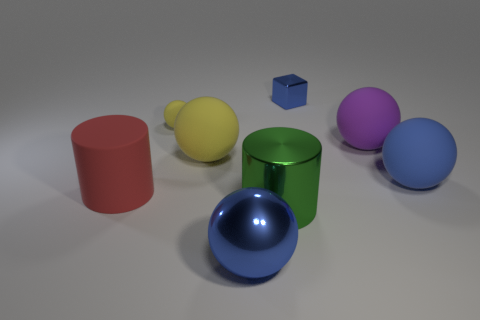There is a big green object that is the same shape as the red matte thing; what is it made of?
Provide a short and direct response. Metal. What is the shape of the large rubber thing right of the big purple matte thing?
Your response must be concise. Sphere. What number of other green objects are the same shape as the big green thing?
Offer a terse response. 0. Are there the same number of red things that are to the right of the large red rubber cylinder and blue spheres behind the shiny cube?
Offer a terse response. Yes. Are there any small cyan balls that have the same material as the large red object?
Offer a terse response. No. Is the large purple object made of the same material as the small ball?
Offer a very short reply. Yes. What number of blue things are tiny metal blocks or metallic things?
Ensure brevity in your answer.  2. Is the number of big blue matte balls behind the tiny shiny cube greater than the number of small blue shiny things?
Give a very brief answer. No. Is there a rubber cylinder of the same color as the tiny block?
Offer a very short reply. No. The red matte cylinder has what size?
Provide a succinct answer. Large. 